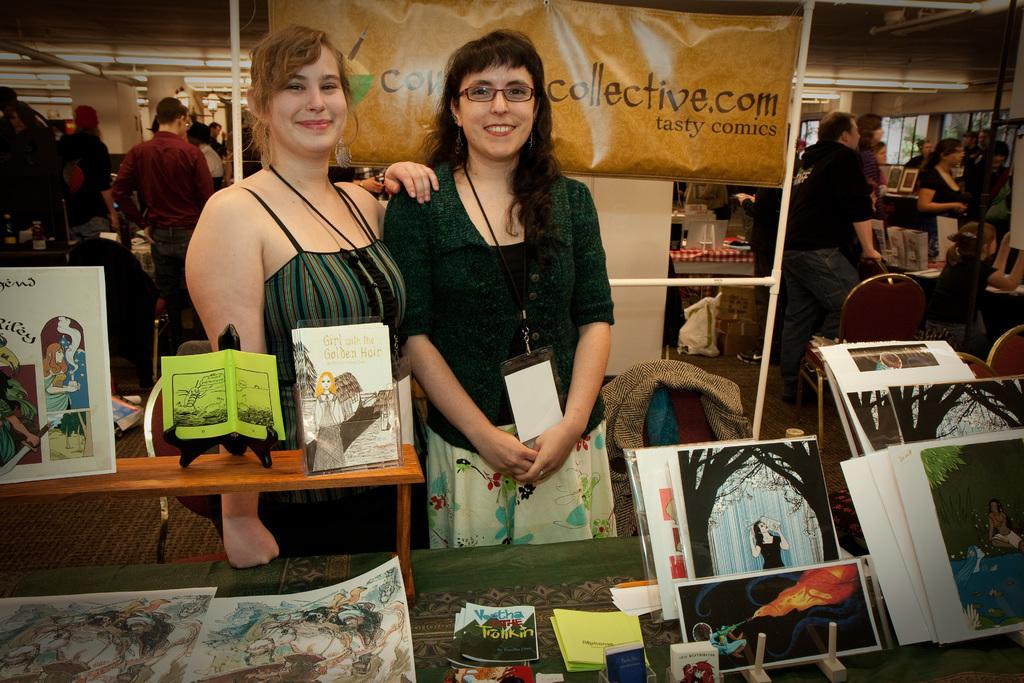How many women are in the image? There are two women in the image. What are the women doing in the image? The women are standing near a table. What is on the table in the image? There are photographs placed on the table. What can be seen in the background of the image? There are people in the background of the image, and they are near tables. What is the size of the heart-shaped paper on the table? There is no heart-shaped paper present on the table in the image. 